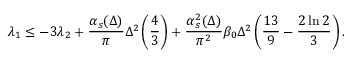Convert formula to latex. <formula><loc_0><loc_0><loc_500><loc_500>\lambda _ { 1 } \leq - 3 \lambda _ { 2 } + { \frac { \alpha _ { s } ( \Delta ) } { \pi } } \Delta ^ { 2 } \left ( { \frac { 4 } { 3 } } \right ) + { \frac { \alpha _ { s } ^ { 2 } ( \Delta ) } { \pi ^ { 2 } } } \beta _ { 0 } \Delta ^ { 2 } \left ( { \frac { 1 3 } { 9 } } - { \frac { 2 \ln 2 } { 3 } } \right ) .</formula> 